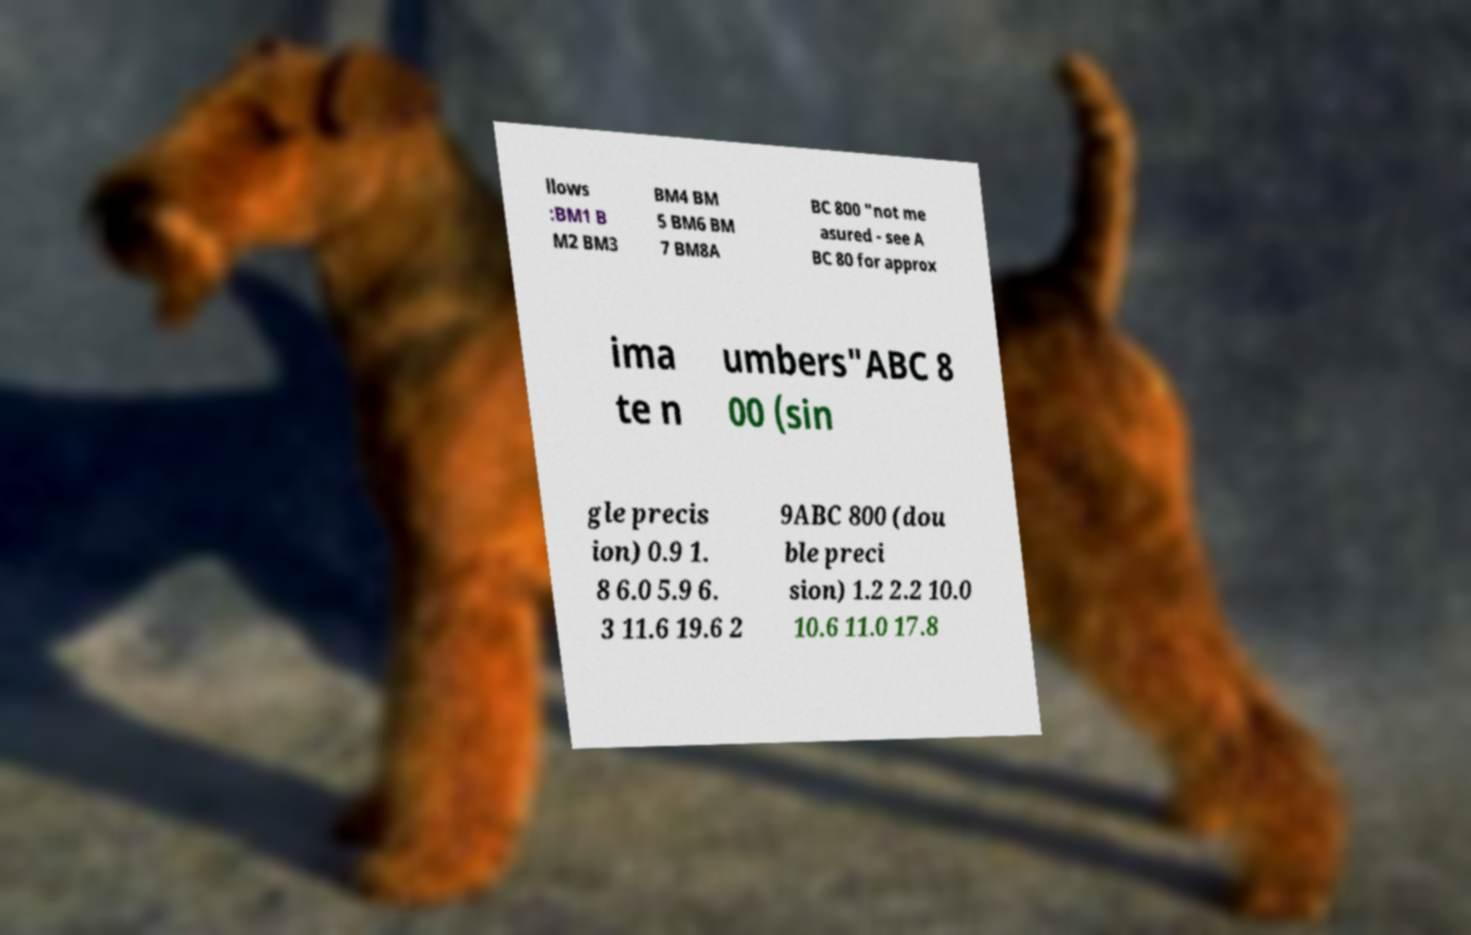Could you assist in decoding the text presented in this image and type it out clearly? llows :BM1 B M2 BM3 BM4 BM 5 BM6 BM 7 BM8A BC 800 "not me asured - see A BC 80 for approx ima te n umbers"ABC 8 00 (sin gle precis ion) 0.9 1. 8 6.0 5.9 6. 3 11.6 19.6 2 9ABC 800 (dou ble preci sion) 1.2 2.2 10.0 10.6 11.0 17.8 